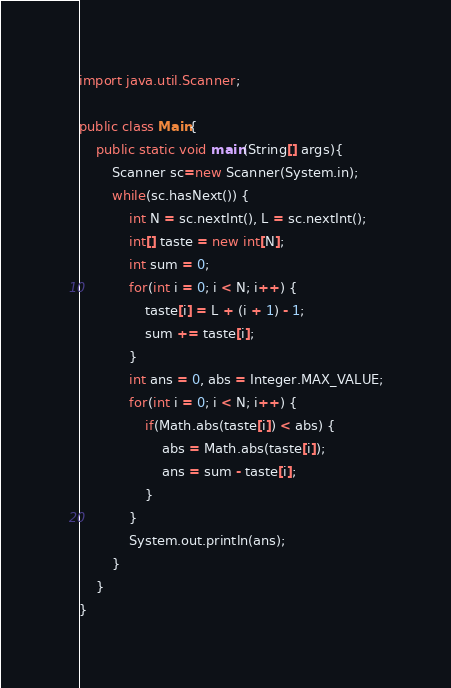<code> <loc_0><loc_0><loc_500><loc_500><_Java_>import java.util.Scanner;

public class Main{
	public static void main(String[] args){
		Scanner sc=new Scanner(System.in);
		while(sc.hasNext()) {
			int N = sc.nextInt(), L = sc.nextInt();
			int[] taste = new int[N];
			int sum = 0;
			for(int i = 0; i < N; i++) {
				taste[i] = L + (i + 1) - 1;
				sum += taste[i];
			}
			int ans = 0, abs = Integer.MAX_VALUE;
			for(int i = 0; i < N; i++) {
				if(Math.abs(taste[i]) < abs) {
					abs = Math.abs(taste[i]);
					ans = sum - taste[i];
				}
			}
			System.out.println(ans);
		}
	}
}</code> 